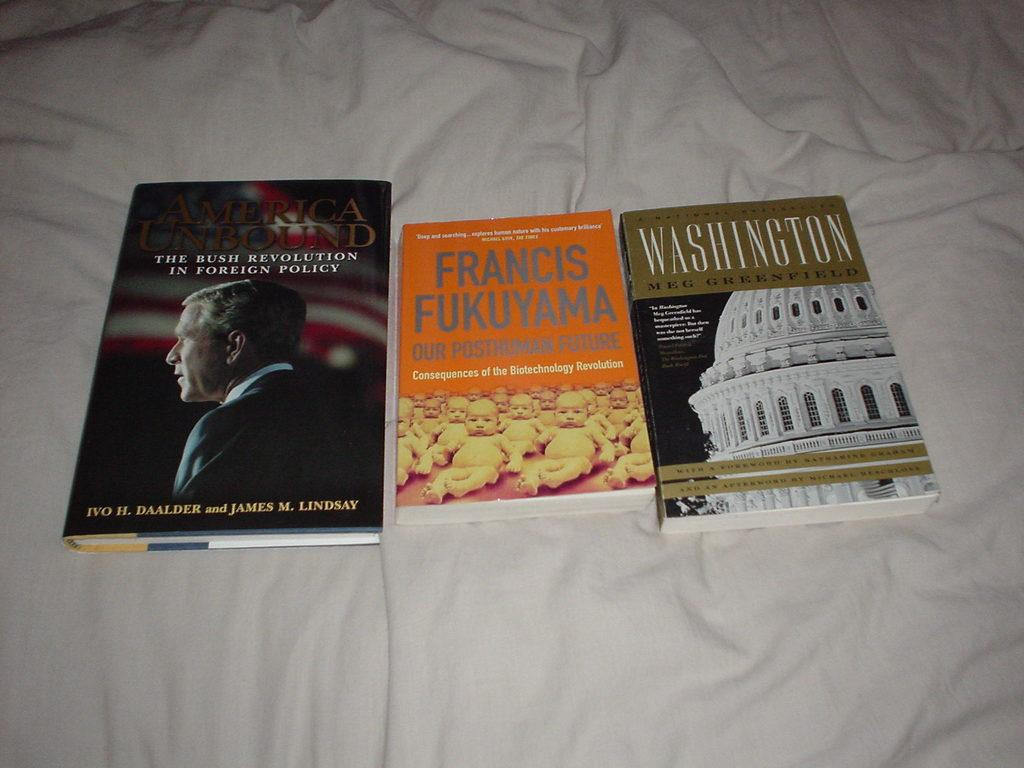<image>
Write a terse but informative summary of the picture. A book by Meg Greenfield is next to two other books. 